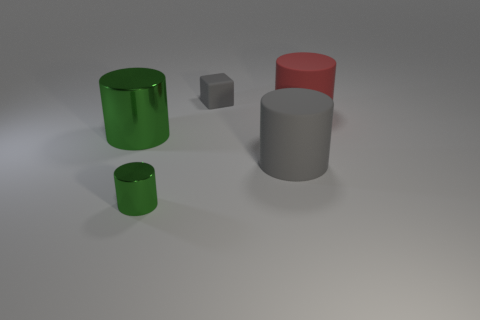Is the number of tiny yellow cubes greater than the number of tiny metallic objects?
Your answer should be compact. No. There is a large rubber cylinder left of the big red rubber cylinder; does it have the same color as the tiny object in front of the small cube?
Provide a succinct answer. No. Are the tiny thing that is behind the large red cylinder and the cylinder behind the large green cylinder made of the same material?
Your response must be concise. Yes. How many green matte objects have the same size as the gray rubber cube?
Your answer should be compact. 0. Are there fewer big green metallic things than tiny blue blocks?
Offer a terse response. No. There is a big thing in front of the green object that is behind the gray matte cylinder; what shape is it?
Your answer should be compact. Cylinder. The red object that is the same size as the gray cylinder is what shape?
Offer a terse response. Cylinder. Is there another small green object of the same shape as the small matte thing?
Keep it short and to the point. No. What is the material of the red cylinder?
Provide a succinct answer. Rubber. There is a small green cylinder; are there any shiny things in front of it?
Your response must be concise. No. 